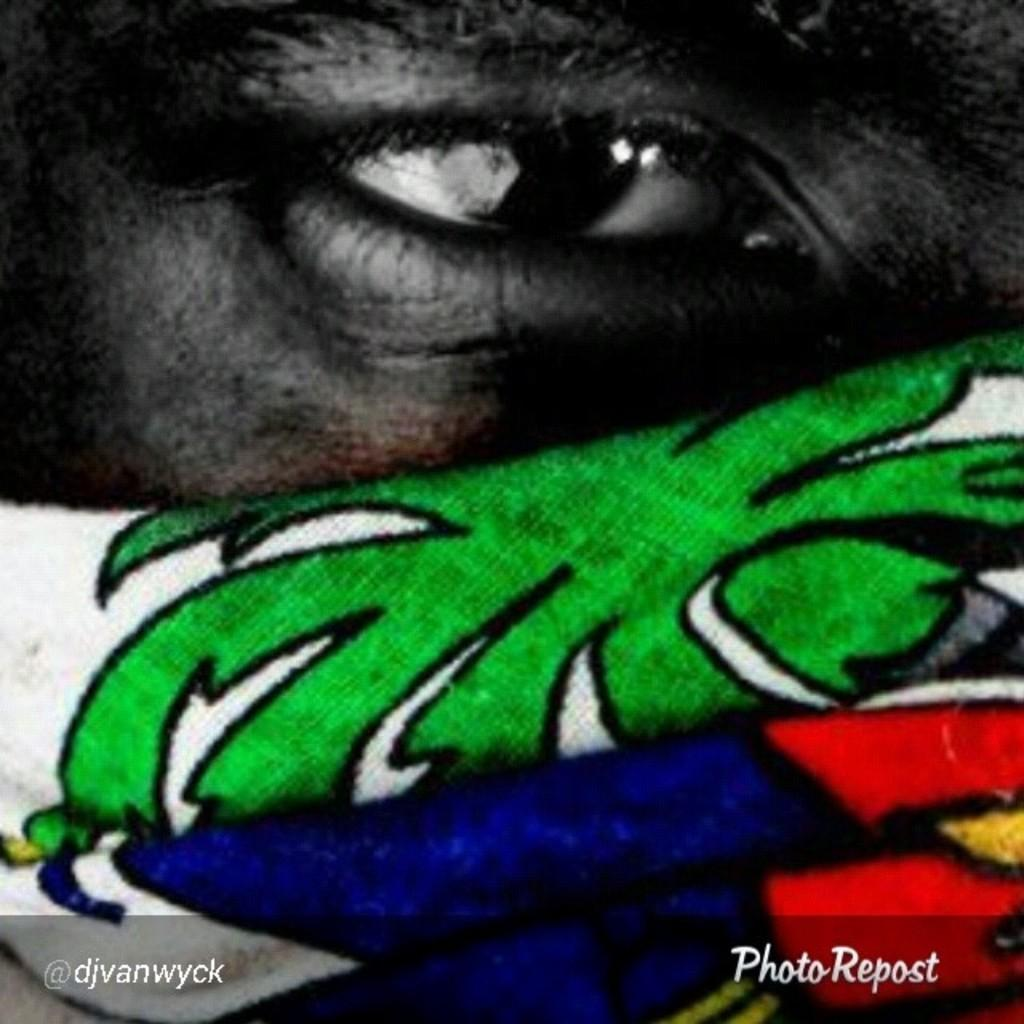What is the main subject of the image? The main subject of the image is a person's eye. What else can be seen in the image besides the eye? There are paintings on a face and text visible in the image. What type of feather is being used to create the text in the image? There is no feather present in the image; the text is not created using a feather. 